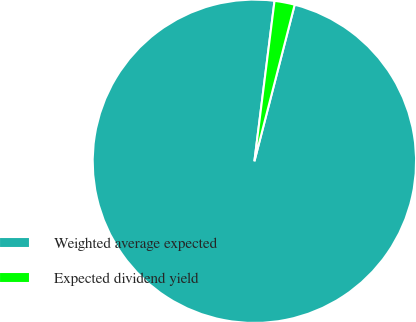Convert chart. <chart><loc_0><loc_0><loc_500><loc_500><pie_chart><fcel>Weighted average expected<fcel>Expected dividend yield<nl><fcel>97.98%<fcel>2.02%<nl></chart> 